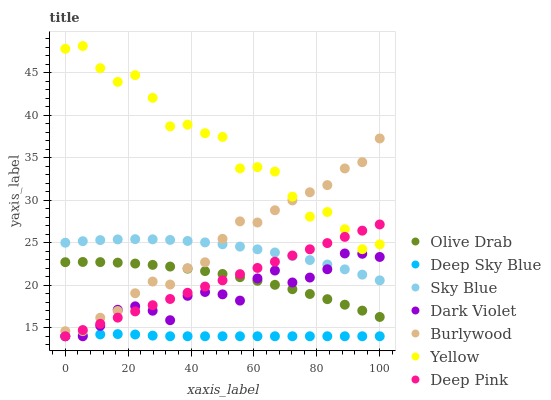Does Deep Sky Blue have the minimum area under the curve?
Answer yes or no. Yes. Does Yellow have the maximum area under the curve?
Answer yes or no. Yes. Does Burlywood have the minimum area under the curve?
Answer yes or no. No. Does Burlywood have the maximum area under the curve?
Answer yes or no. No. Is Deep Pink the smoothest?
Answer yes or no. Yes. Is Yellow the roughest?
Answer yes or no. Yes. Is Burlywood the smoothest?
Answer yes or no. No. Is Burlywood the roughest?
Answer yes or no. No. Does Deep Pink have the lowest value?
Answer yes or no. Yes. Does Burlywood have the lowest value?
Answer yes or no. No. Does Yellow have the highest value?
Answer yes or no. Yes. Does Burlywood have the highest value?
Answer yes or no. No. Is Deep Sky Blue less than Olive Drab?
Answer yes or no. Yes. Is Olive Drab greater than Deep Sky Blue?
Answer yes or no. Yes. Does Yellow intersect Deep Pink?
Answer yes or no. Yes. Is Yellow less than Deep Pink?
Answer yes or no. No. Is Yellow greater than Deep Pink?
Answer yes or no. No. Does Deep Sky Blue intersect Olive Drab?
Answer yes or no. No. 